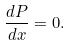<formula> <loc_0><loc_0><loc_500><loc_500>\frac { d P } { d x } = 0 .</formula> 